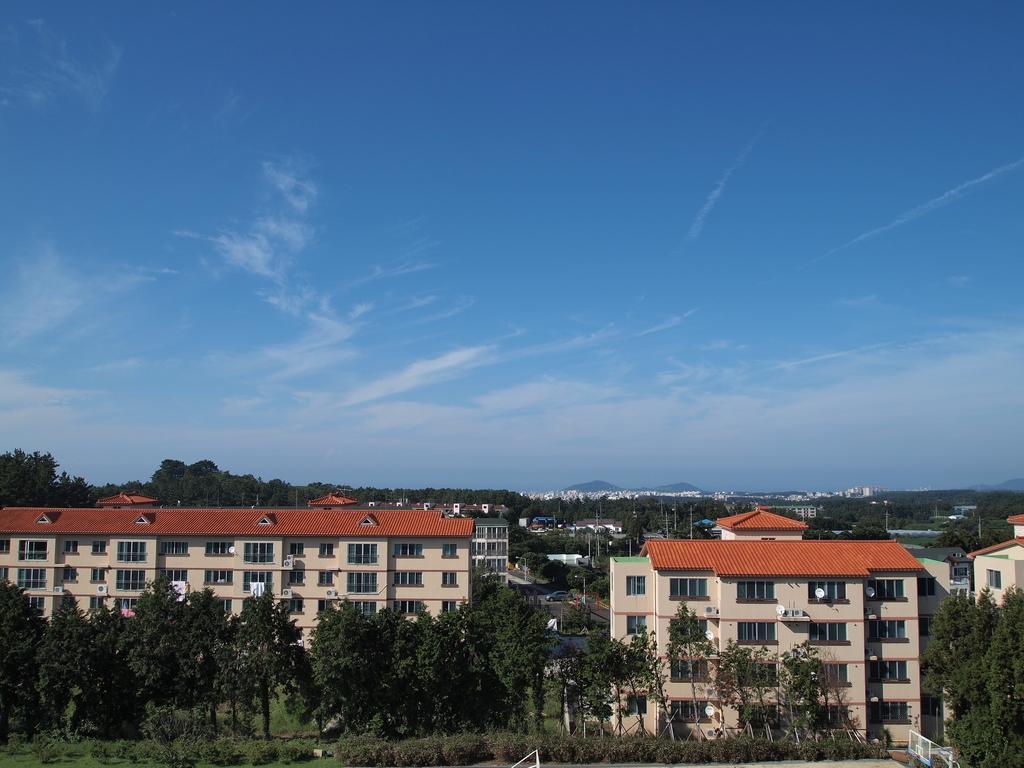What type of scene is depicted in the image? The image is a view of a city. What structures can be seen in the image? There are buildings in the image. Are there any natural elements present in the image? Yes, there are trees in the image. What is visible in the background of the image? The sky is visible in the image. How many bushes can be seen in the image? There are no bushes present in the image. What type of heart is visible in the image? There is no heart present in the image. 